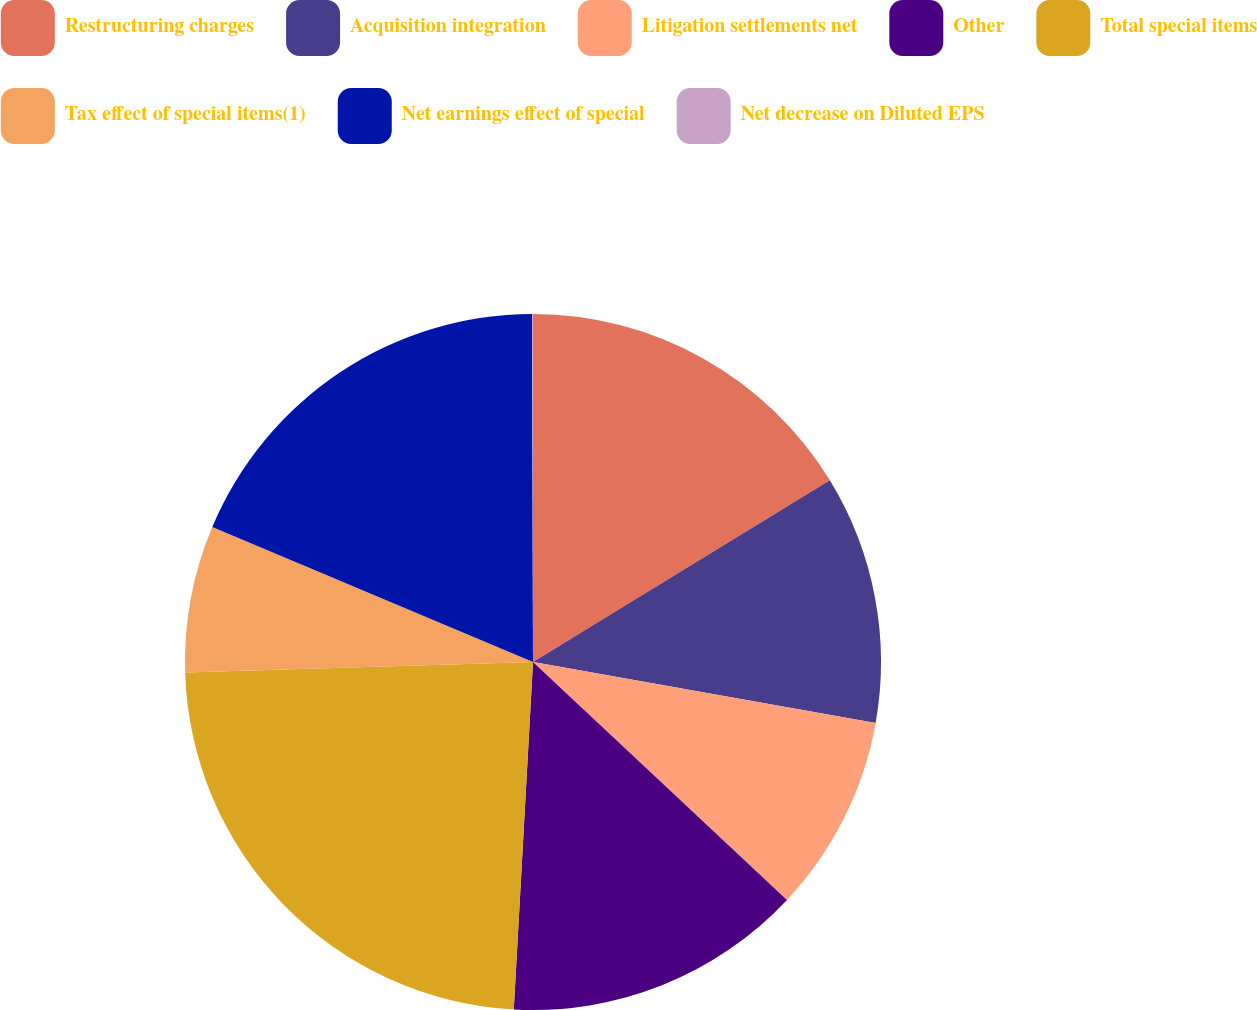<chart> <loc_0><loc_0><loc_500><loc_500><pie_chart><fcel>Restructuring charges<fcel>Acquisition integration<fcel>Litigation settlements net<fcel>Other<fcel>Total special items<fcel>Tax effect of special items(1)<fcel>Net earnings effect of special<fcel>Net decrease on Diluted EPS<nl><fcel>16.26%<fcel>11.54%<fcel>9.18%<fcel>13.9%<fcel>23.64%<fcel>6.82%<fcel>18.62%<fcel>0.04%<nl></chart> 